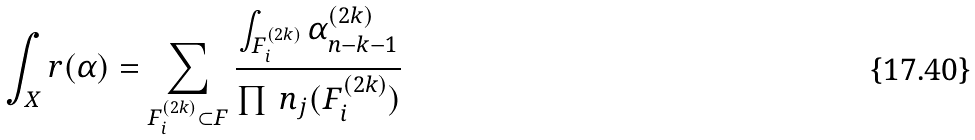Convert formula to latex. <formula><loc_0><loc_0><loc_500><loc_500>\int _ { X } r ( \alpha ) = \sum _ { F _ { i } ^ { ( 2 k ) } \subset F } \frac { \int _ { F _ { i } ^ { ( 2 k ) } } \alpha _ { n - k - 1 } ^ { ( 2 k ) } } { \prod \, n _ { j } ( F _ { i } ^ { ( 2 k ) } ) }</formula> 